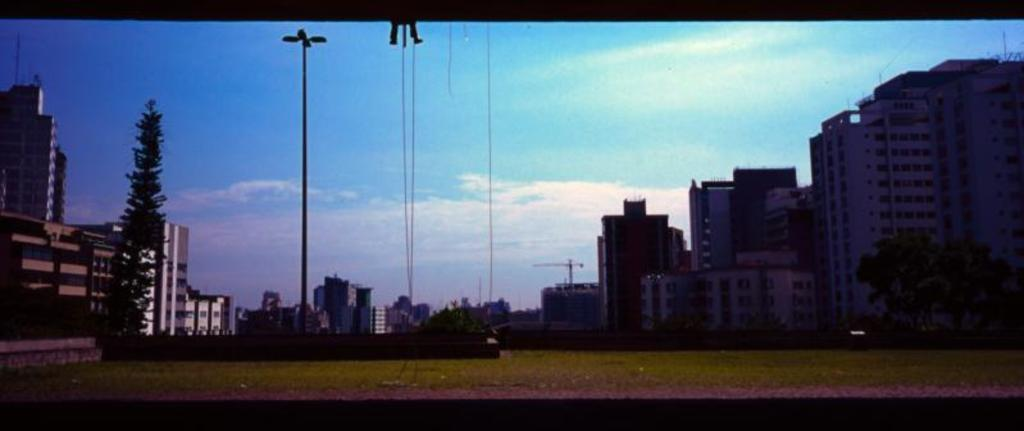What type of landscape is depicted in the image? There is a grassland in the image. What can be seen in the distance behind the grassland? There are trees and buildings in the background of the image. What part of the natural environment is visible in the image? The sky is visible in the background of the image. What type of goat can be seen climbing the branch of a tree in the image? There is no goat or tree branch present in the image. What color is the flag flying above the buildings in the image? There is no flag visible in the image. 